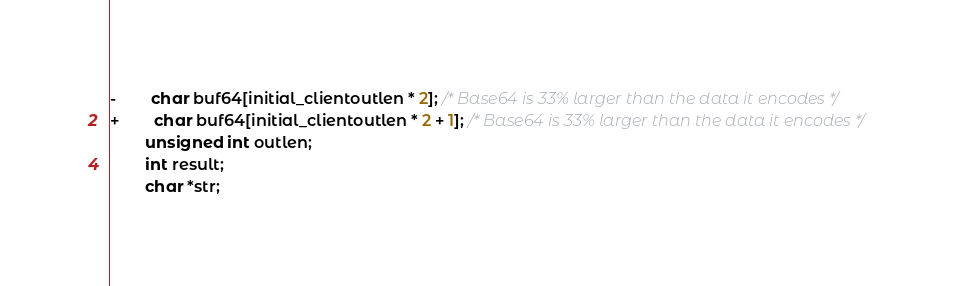<code> <loc_0><loc_0><loc_500><loc_500><_C_>-	    char buf64[initial_clientoutlen * 2]; /* Base64 is 33% larger than the data it encodes */
+	    char buf64[initial_clientoutlen * 2 + 1]; /* Base64 is 33% larger than the data it encodes */
 	    unsigned int outlen;
 	    int result;
 	    char *str;
</code> 